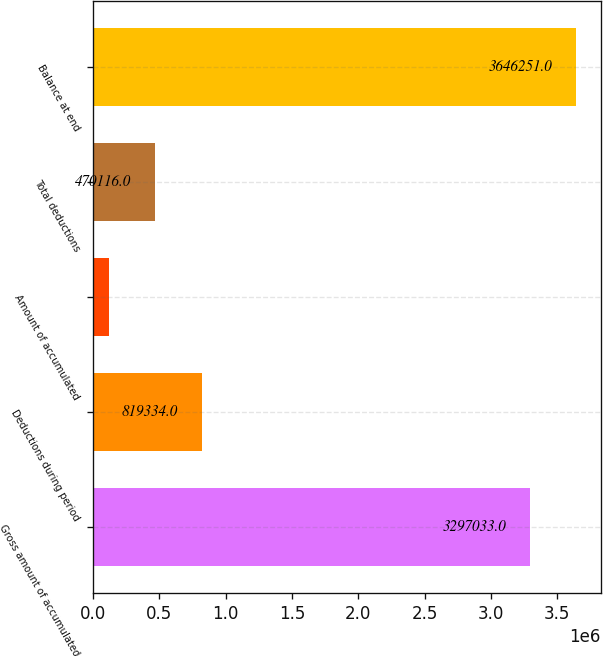<chart> <loc_0><loc_0><loc_500><loc_500><bar_chart><fcel>Gross amount of accumulated<fcel>Deductions during period<fcel>Amount of accumulated<fcel>Total deductions<fcel>Balance at end<nl><fcel>3.29703e+06<fcel>819334<fcel>120898<fcel>470116<fcel>3.64625e+06<nl></chart> 